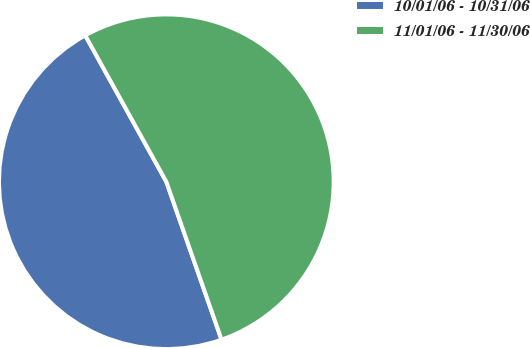<chart> <loc_0><loc_0><loc_500><loc_500><pie_chart><fcel>10/01/06 - 10/31/06<fcel>11/01/06 - 11/30/06<nl><fcel>47.3%<fcel>52.7%<nl></chart> 